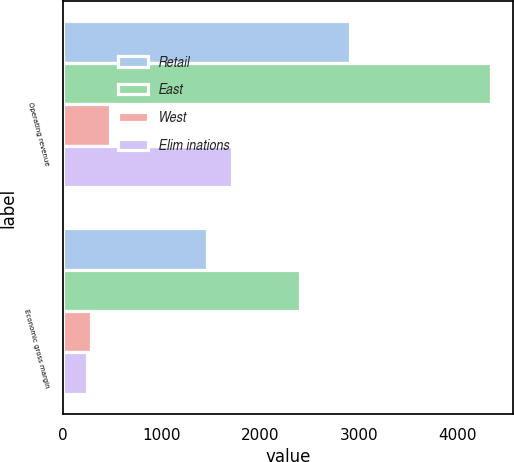Convert chart to OTSL. <chart><loc_0><loc_0><loc_500><loc_500><stacked_bar_chart><ecel><fcel>Operating revenue<fcel>Economic gross margin<nl><fcel>Retail<fcel>2909<fcel>1458<nl><fcel>East<fcel>4339<fcel>2400<nl><fcel>West<fcel>475<fcel>283<nl><fcel>Elim inations<fcel>1713<fcel>245<nl></chart> 